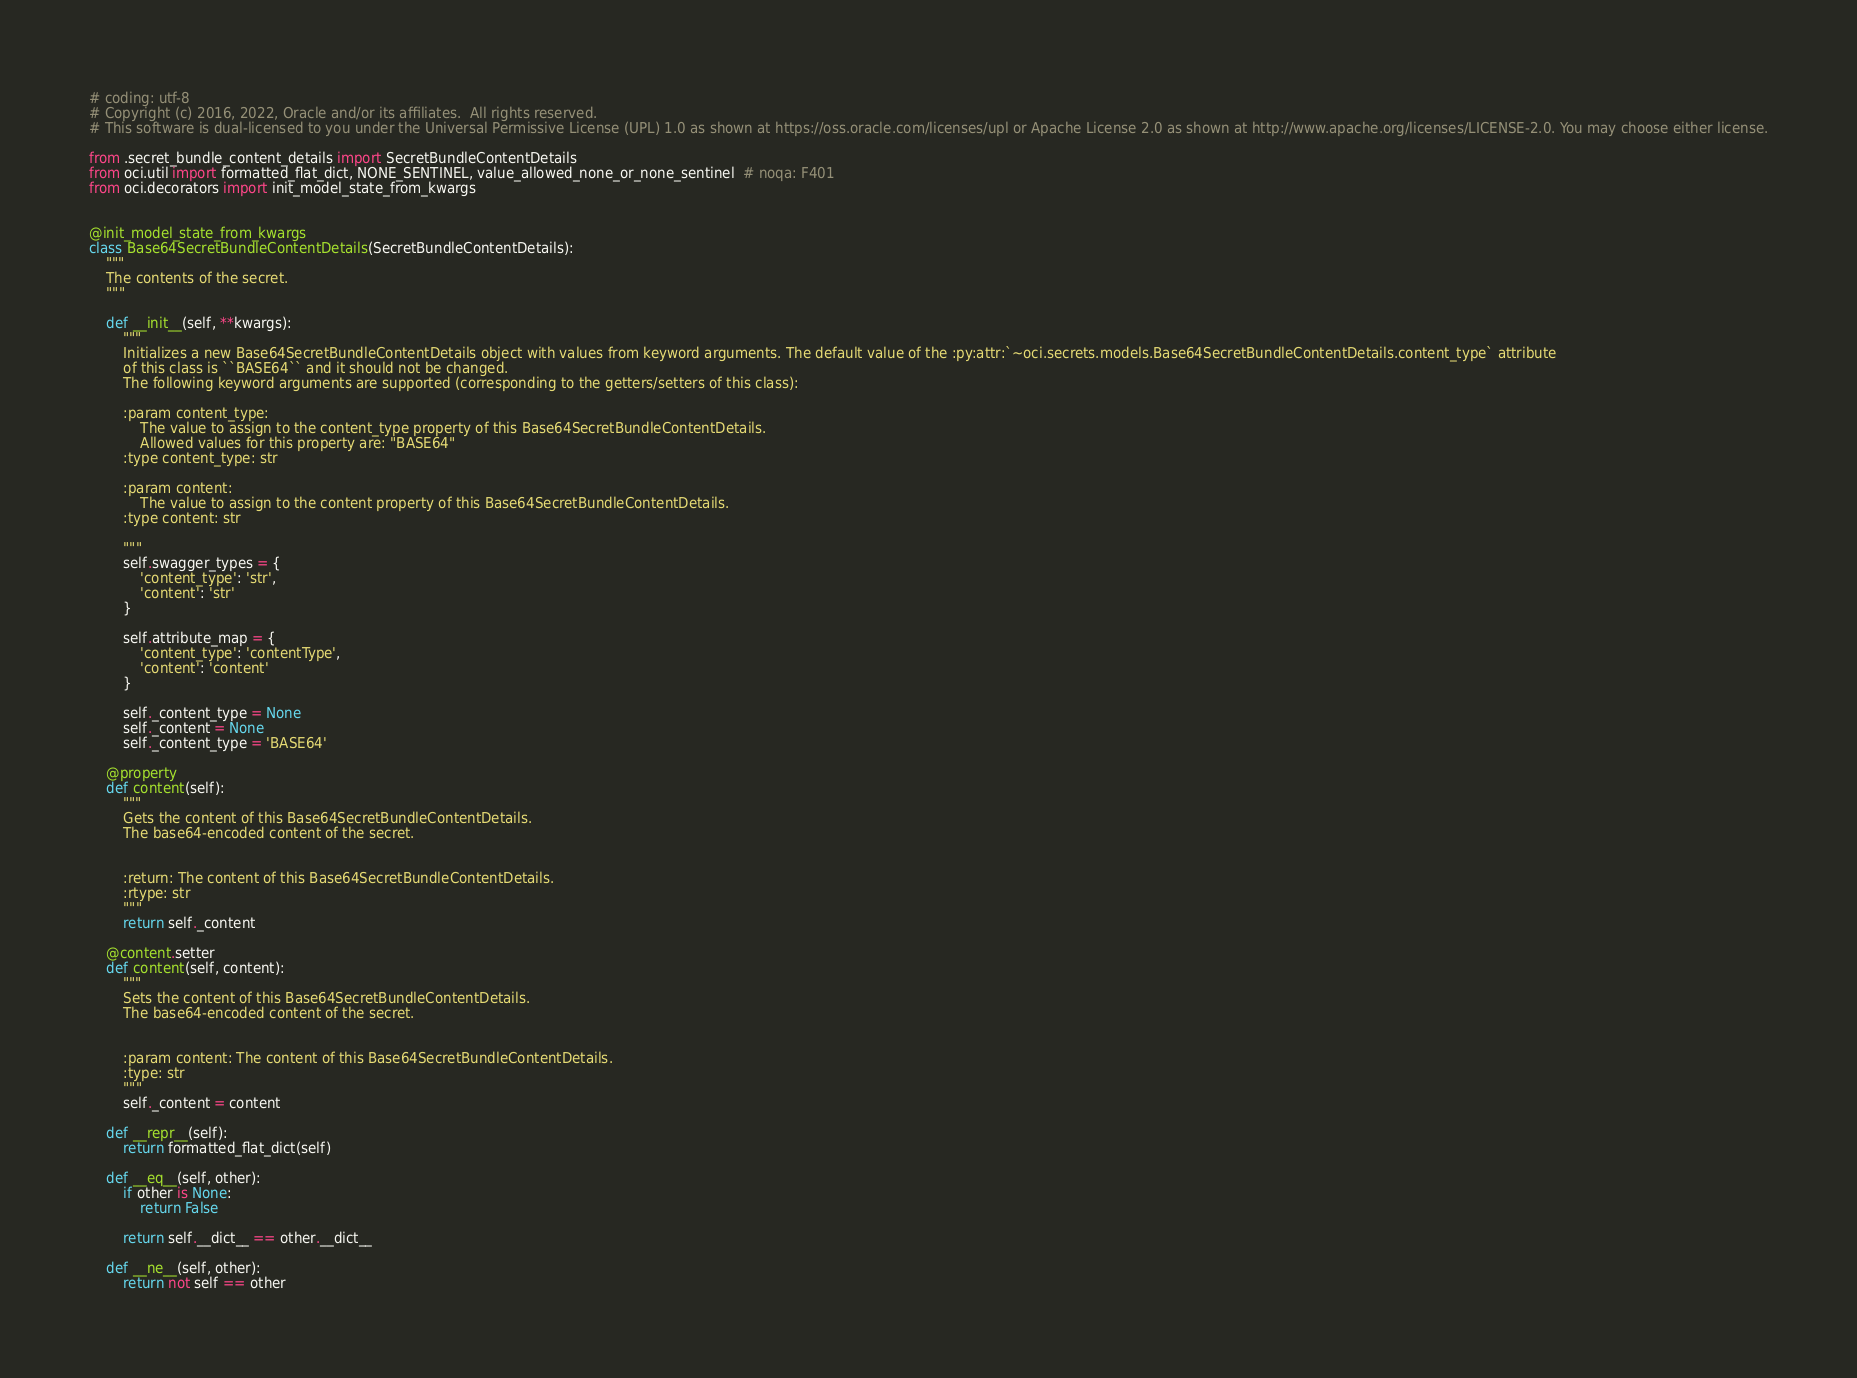<code> <loc_0><loc_0><loc_500><loc_500><_Python_># coding: utf-8
# Copyright (c) 2016, 2022, Oracle and/or its affiliates.  All rights reserved.
# This software is dual-licensed to you under the Universal Permissive License (UPL) 1.0 as shown at https://oss.oracle.com/licenses/upl or Apache License 2.0 as shown at http://www.apache.org/licenses/LICENSE-2.0. You may choose either license.

from .secret_bundle_content_details import SecretBundleContentDetails
from oci.util import formatted_flat_dict, NONE_SENTINEL, value_allowed_none_or_none_sentinel  # noqa: F401
from oci.decorators import init_model_state_from_kwargs


@init_model_state_from_kwargs
class Base64SecretBundleContentDetails(SecretBundleContentDetails):
    """
    The contents of the secret.
    """

    def __init__(self, **kwargs):
        """
        Initializes a new Base64SecretBundleContentDetails object with values from keyword arguments. The default value of the :py:attr:`~oci.secrets.models.Base64SecretBundleContentDetails.content_type` attribute
        of this class is ``BASE64`` and it should not be changed.
        The following keyword arguments are supported (corresponding to the getters/setters of this class):

        :param content_type:
            The value to assign to the content_type property of this Base64SecretBundleContentDetails.
            Allowed values for this property are: "BASE64"
        :type content_type: str

        :param content:
            The value to assign to the content property of this Base64SecretBundleContentDetails.
        :type content: str

        """
        self.swagger_types = {
            'content_type': 'str',
            'content': 'str'
        }

        self.attribute_map = {
            'content_type': 'contentType',
            'content': 'content'
        }

        self._content_type = None
        self._content = None
        self._content_type = 'BASE64'

    @property
    def content(self):
        """
        Gets the content of this Base64SecretBundleContentDetails.
        The base64-encoded content of the secret.


        :return: The content of this Base64SecretBundleContentDetails.
        :rtype: str
        """
        return self._content

    @content.setter
    def content(self, content):
        """
        Sets the content of this Base64SecretBundleContentDetails.
        The base64-encoded content of the secret.


        :param content: The content of this Base64SecretBundleContentDetails.
        :type: str
        """
        self._content = content

    def __repr__(self):
        return formatted_flat_dict(self)

    def __eq__(self, other):
        if other is None:
            return False

        return self.__dict__ == other.__dict__

    def __ne__(self, other):
        return not self == other
</code> 